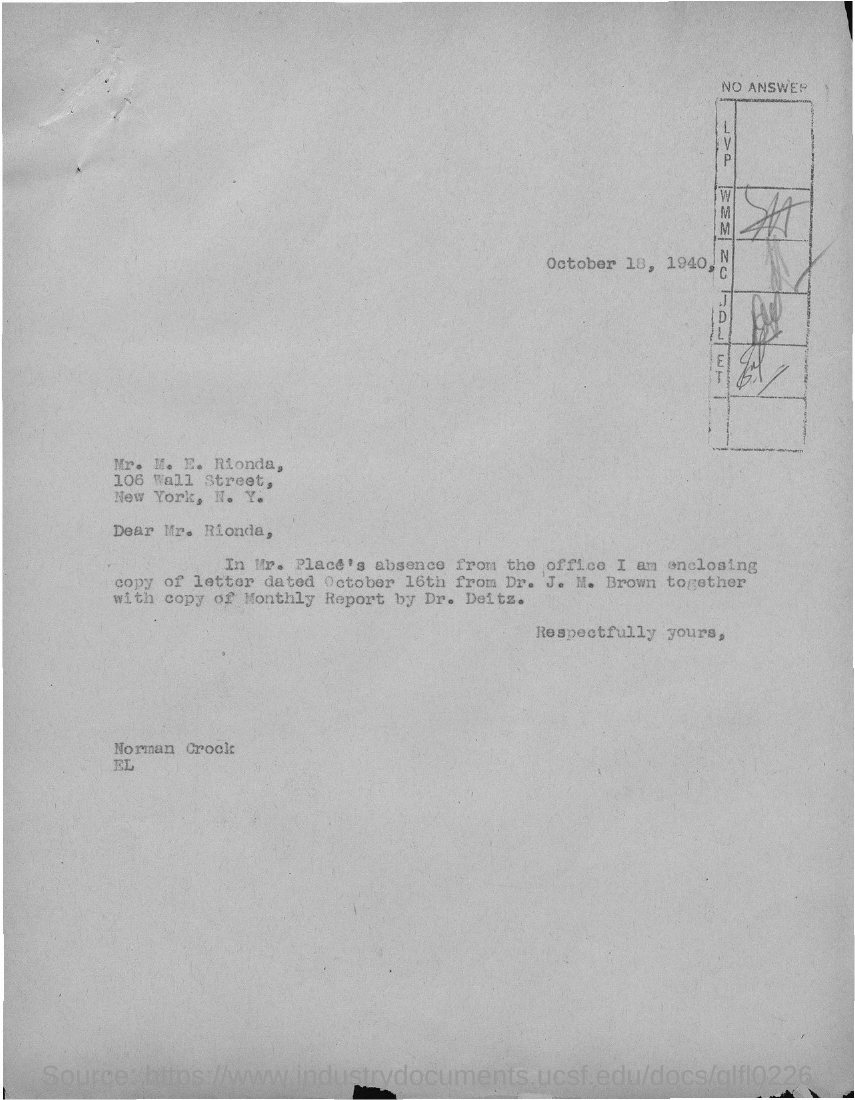Give some essential details in this illustration. The letter is dated October 18, 1940. The letter is addressed to Mr. M. E. Rionda. 